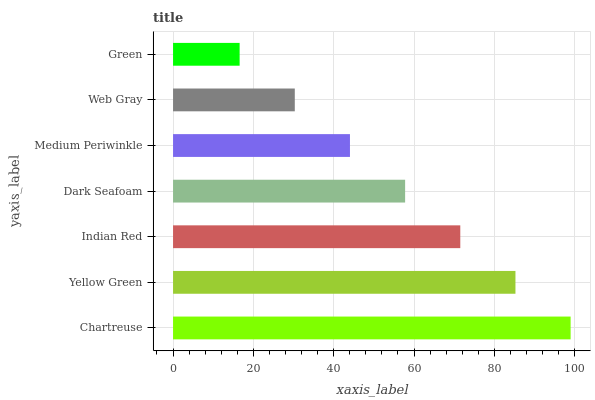Is Green the minimum?
Answer yes or no. Yes. Is Chartreuse the maximum?
Answer yes or no. Yes. Is Yellow Green the minimum?
Answer yes or no. No. Is Yellow Green the maximum?
Answer yes or no. No. Is Chartreuse greater than Yellow Green?
Answer yes or no. Yes. Is Yellow Green less than Chartreuse?
Answer yes or no. Yes. Is Yellow Green greater than Chartreuse?
Answer yes or no. No. Is Chartreuse less than Yellow Green?
Answer yes or no. No. Is Dark Seafoam the high median?
Answer yes or no. Yes. Is Dark Seafoam the low median?
Answer yes or no. Yes. Is Chartreuse the high median?
Answer yes or no. No. Is Green the low median?
Answer yes or no. No. 